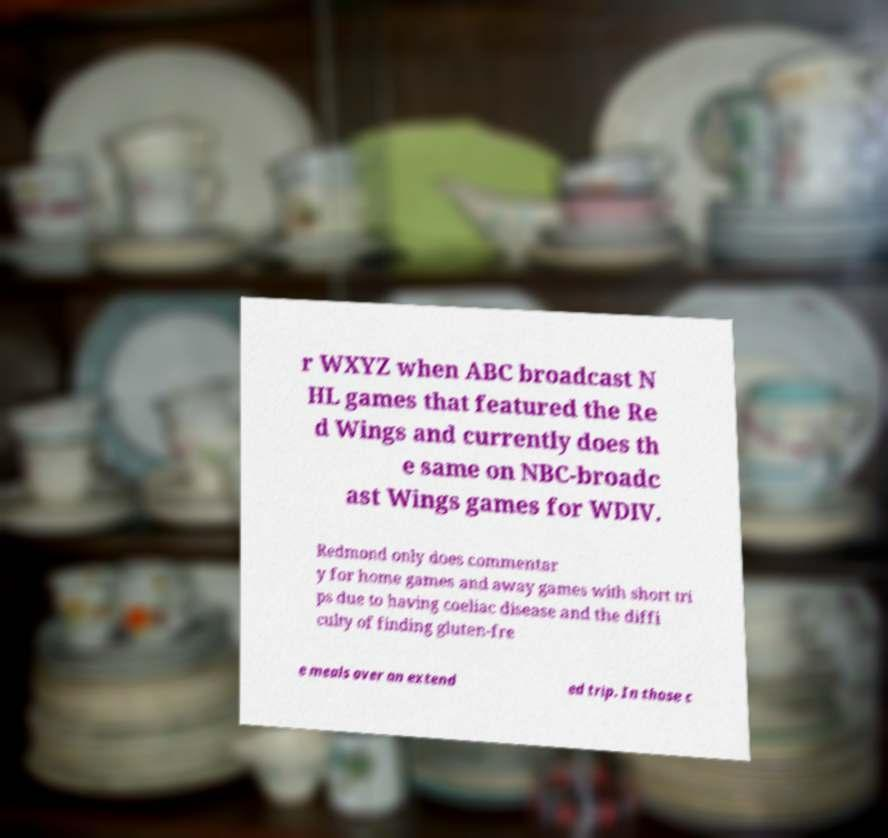Please identify and transcribe the text found in this image. r WXYZ when ABC broadcast N HL games that featured the Re d Wings and currently does th e same on NBC-broadc ast Wings games for WDIV. Redmond only does commentar y for home games and away games with short tri ps due to having coeliac disease and the diffi culty of finding gluten-fre e meals over an extend ed trip. In those c 